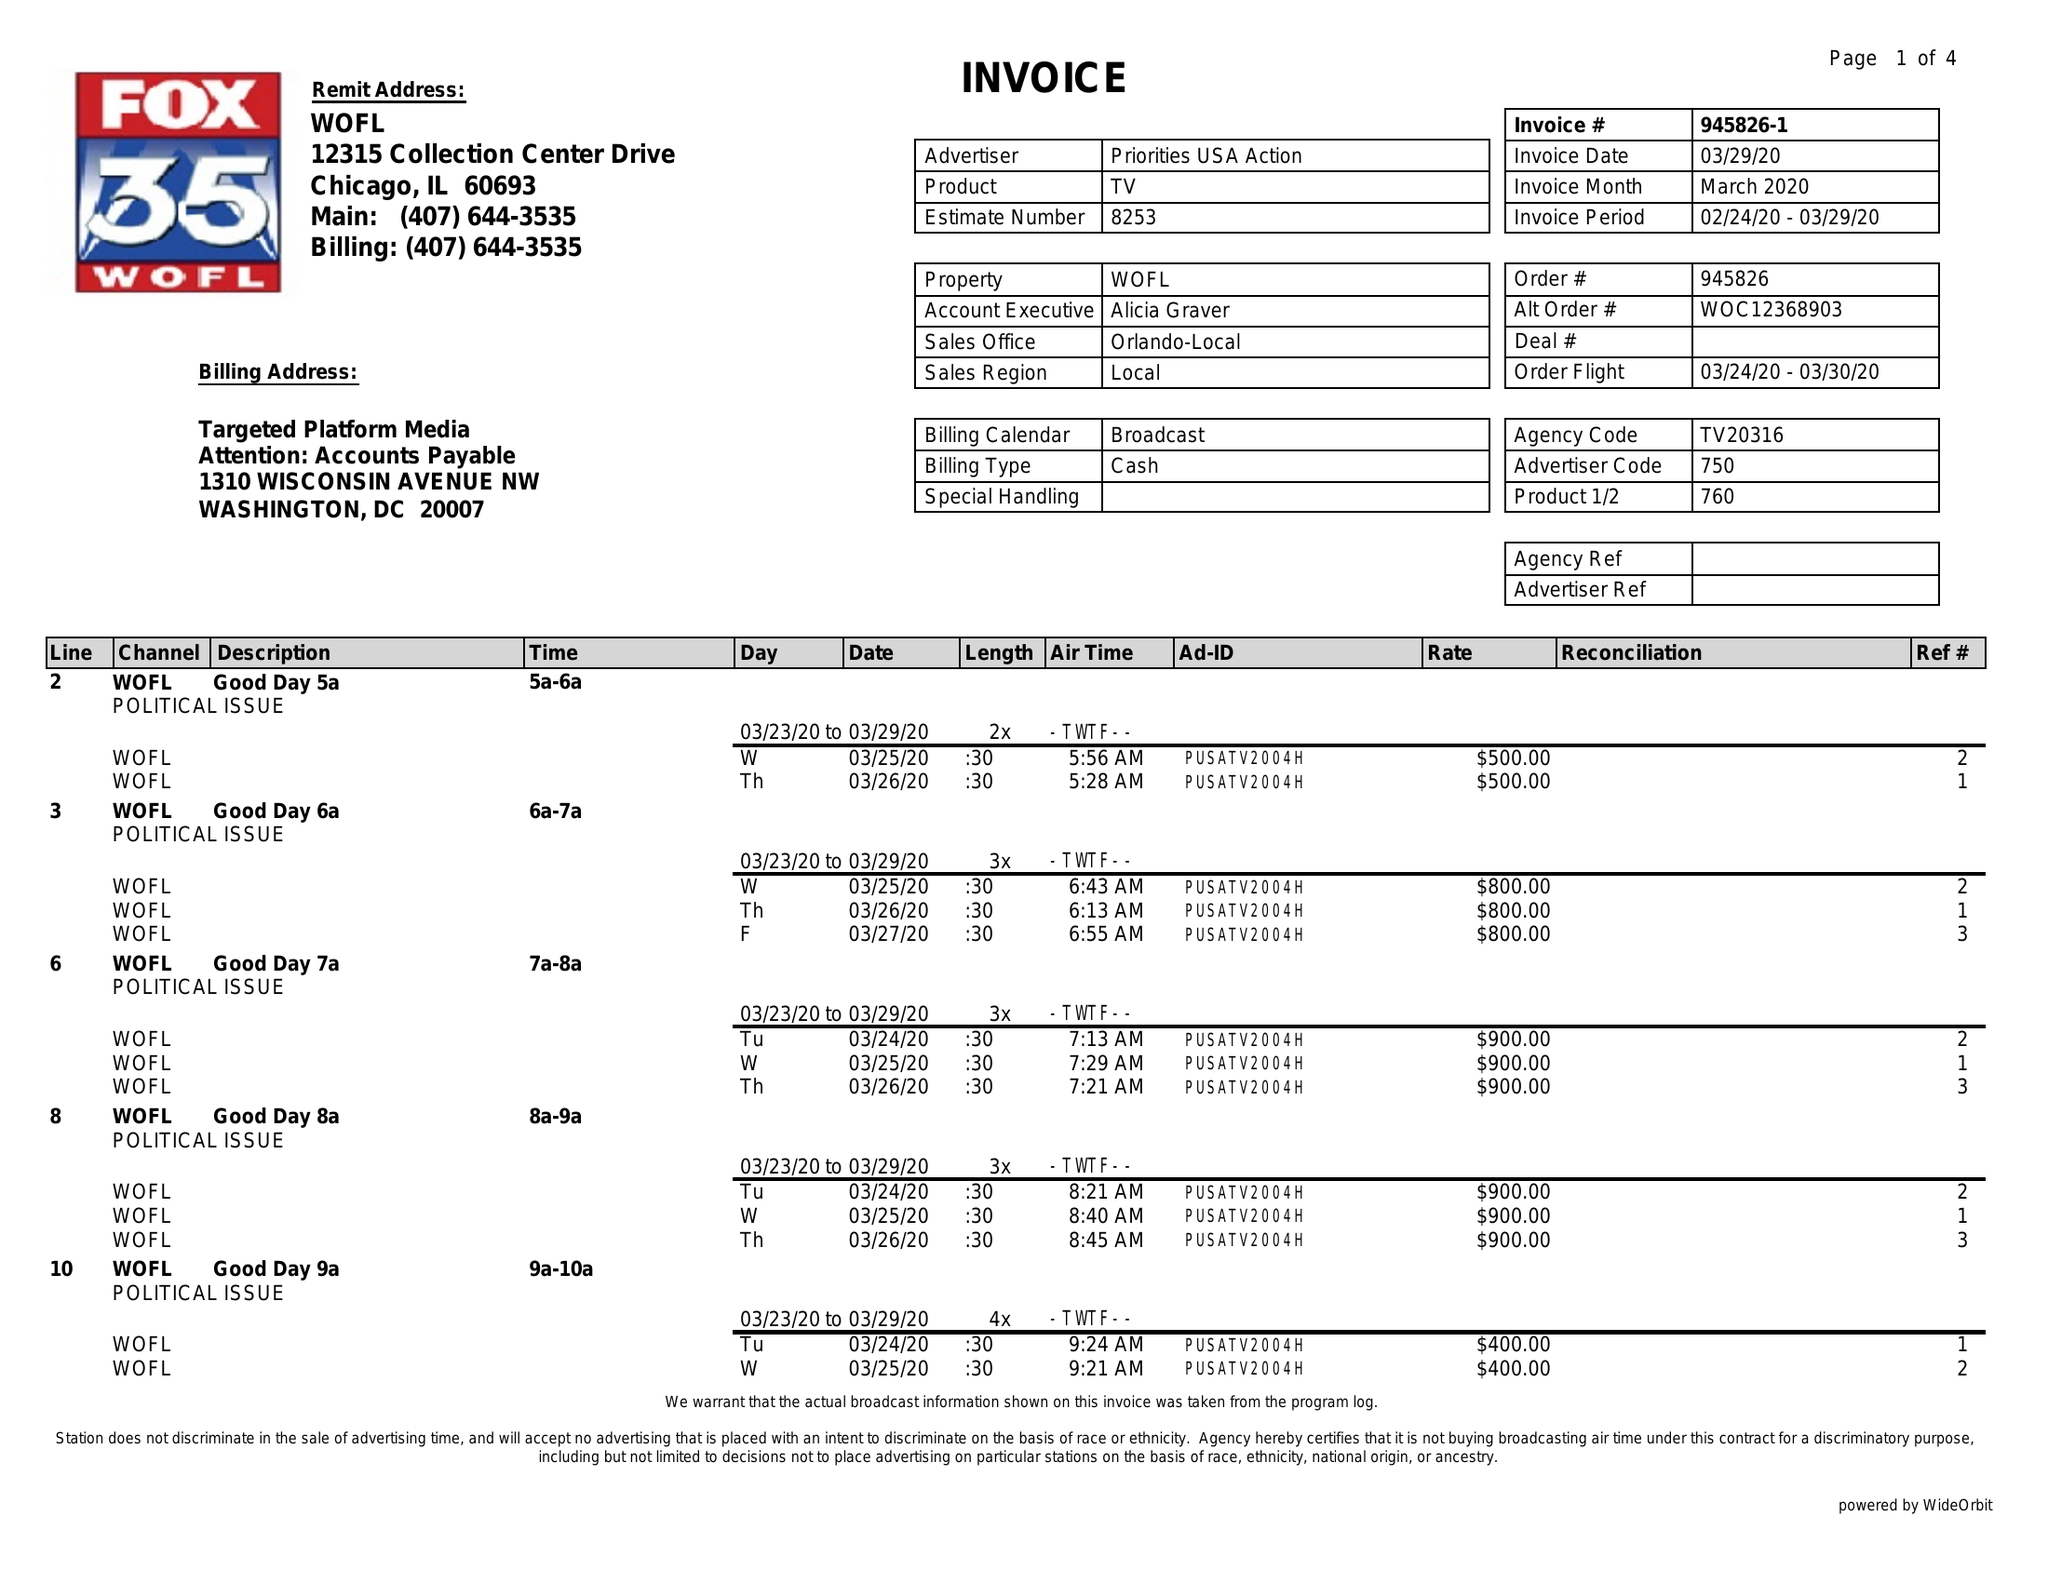What is the value for the flight_to?
Answer the question using a single word or phrase. 03/30/20 